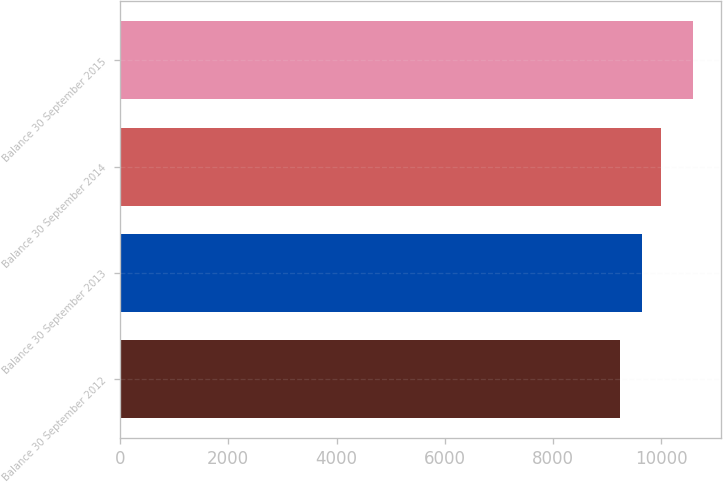Convert chart. <chart><loc_0><loc_0><loc_500><loc_500><bar_chart><fcel>Balance 30 September 2012<fcel>Balance 30 September 2013<fcel>Balance 30 September 2014<fcel>Balance 30 September 2015<nl><fcel>9234.5<fcel>9646.4<fcel>9993.2<fcel>10580.4<nl></chart> 